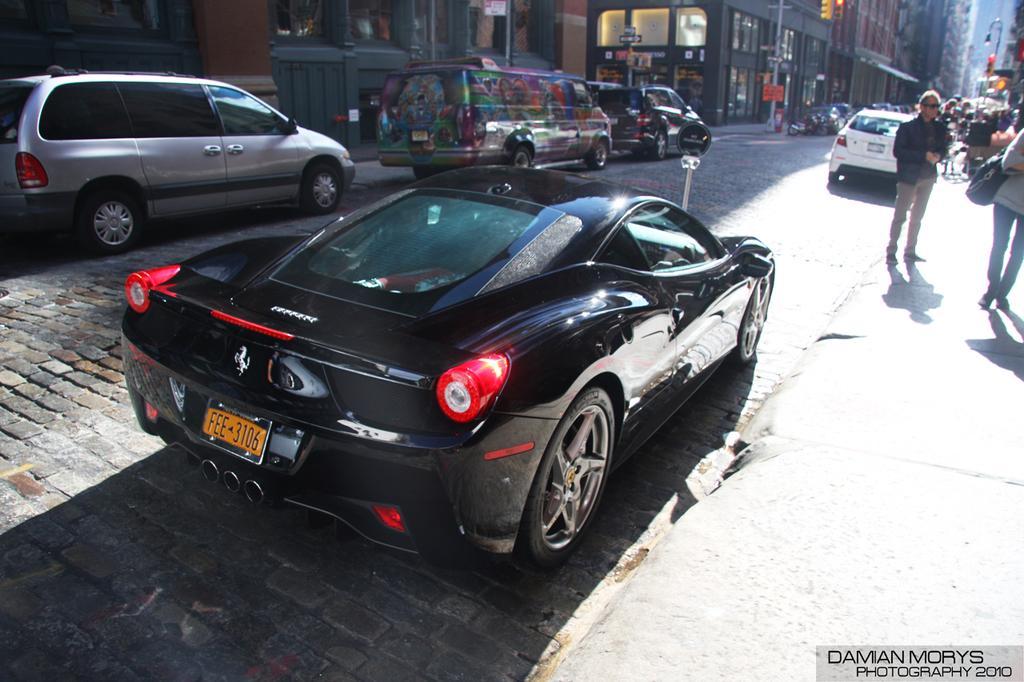Describe this image in one or two sentences. In this image there are buildings truncated towards the top of the image, there is the road truncated towards the left of the image, there are vehicles on the road, there are group of persons, there is a person truncated towards the right of the image, a person is wearing a bag, there are poles truncated towards the top of the image, there are boards, there is a board truncated towards the top of the image, there is text towards the bottom of the image. 